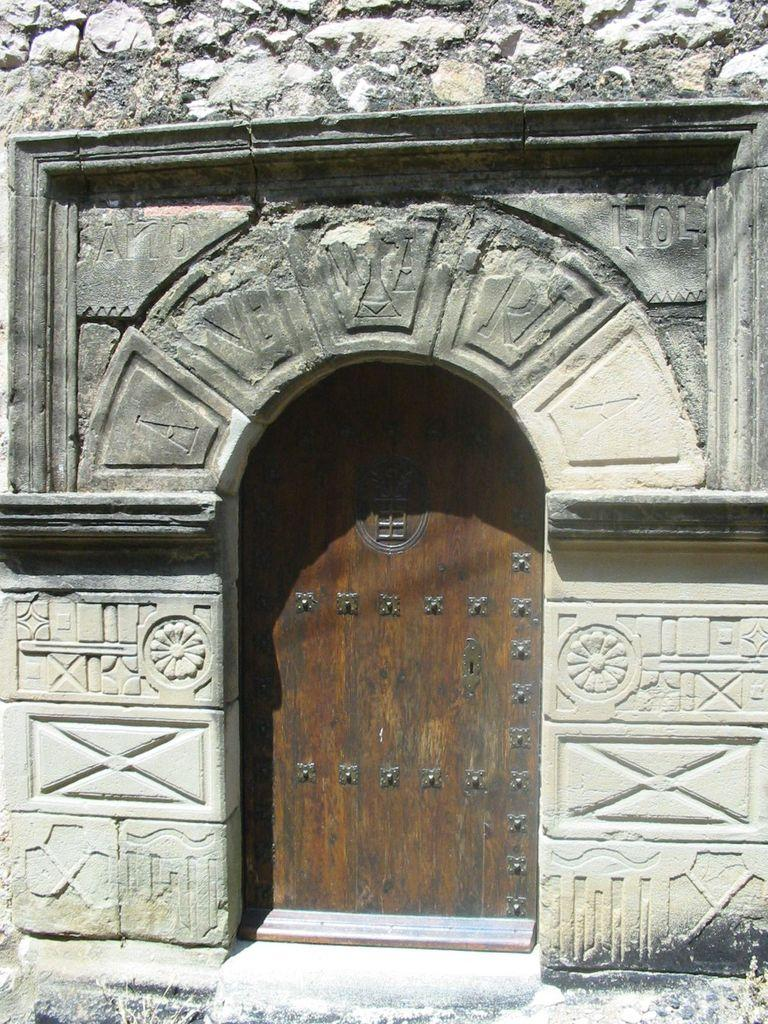What type of structure is visible in the image? There is a wall of a building in the image. Is there any entrance visible in the image? Yes, there is a door in front of the building wall. What creature can be seen interacting with the door in the image? There is no creature present or interacting with the door in the image. 